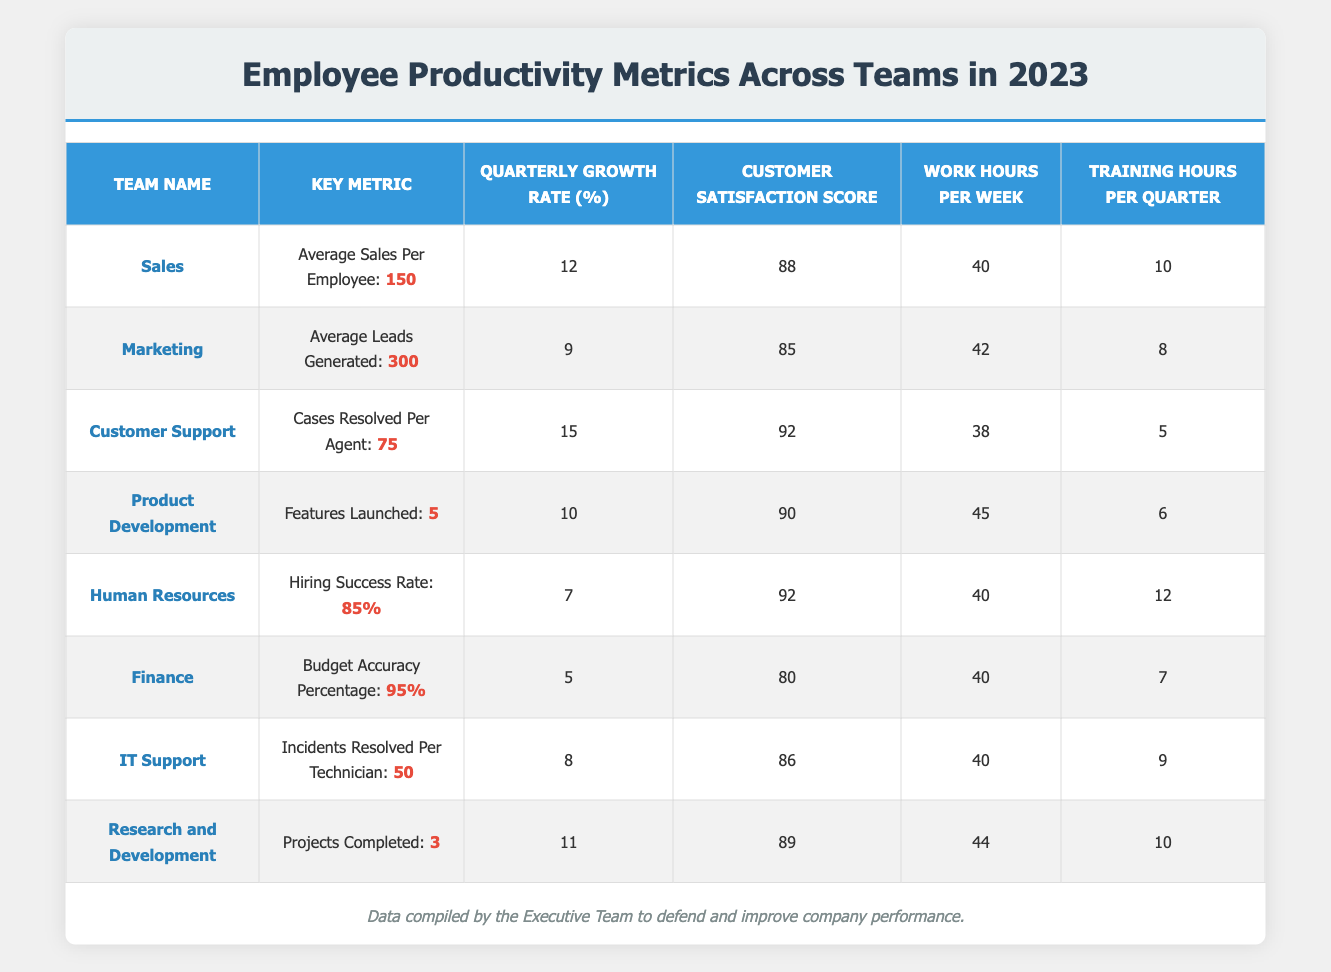What is the highest average sales per employee among the teams? The highest average sales per employee is in the Sales team, which has an average of 150, as highlighted in the table.
Answer: 150 Which team has the highest customer satisfaction score? The team with the highest customer satisfaction score is Customer Support, which scored 92.
Answer: 92 What is the quarterly growth rate for the Human Resources team? The quarterly growth rate for the Human Resources team is 7%, as shown in the table.
Answer: 7 Is the budget accuracy percentage for the Finance team above 90%? Yes, the budget accuracy percentage for the Finance team is 95%, which is above 90%.
Answer: Yes How many training hours per quarter does the Sales team undertake? The Sales team undertakes 10 training hours per quarter, as indicated in the table.
Answer: 10 What is the average work hours per week across all teams? To find the average work hours per week, add the work hours of all teams (40 + 42 + 38 + 45 + 40 + 40 + 40 + 44 = 329) and divide by the number of teams (8). The average is 329/8 = 41.125.
Answer: 41.125 How many features did the Product Development team launch compared to the Customer Support team's cases resolved? The Product Development team launched 5 features while the Customer Support team resolved 75 cases. The difference is 75 - 5 = 70.
Answer: 70 Which team spends the most hours in training per quarter? The team that spends the most training hours per quarter is Human Resources with 12 hours, as displayed in the table.
Answer: 12 Is the quarterly growth rate for the IT Support team greater than the Marketing team's growth rate? No, the quarterly growth rate for the IT Support team is 8%, which is less than the Marketing team's growth rate of 9%.
Answer: No If we add the average sales of the Sales team and the average leads generated by the Marketing team, what is the total? The total is 150 (Sales) + 300 (Marketing) = 450.
Answer: 450 What proportion of training hours does the Customer Support team dedicate compared to the Human Resources team? The Customer Support team dedicates 5 training hours while the Human Resources team dedicates 12 hours. The proportion is 5/12, which is approximately 0.416 or 41.67%.
Answer: 41.67% 